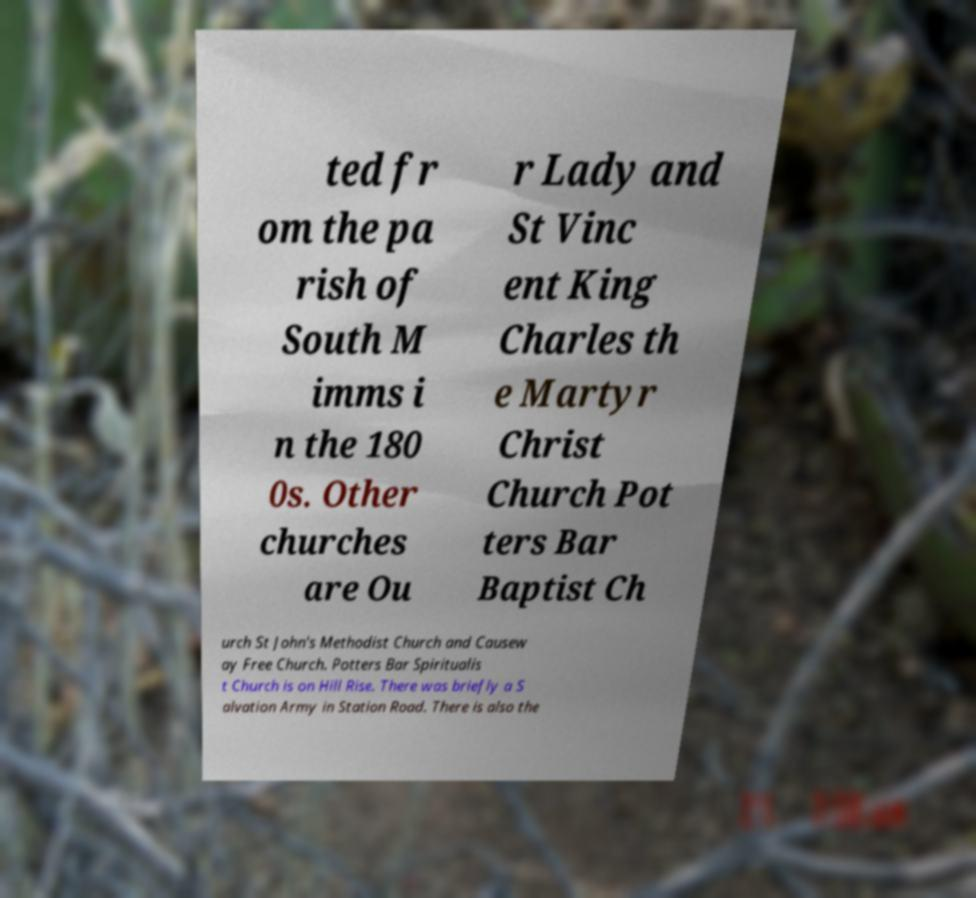I need the written content from this picture converted into text. Can you do that? ted fr om the pa rish of South M imms i n the 180 0s. Other churches are Ou r Lady and St Vinc ent King Charles th e Martyr Christ Church Pot ters Bar Baptist Ch urch St John's Methodist Church and Causew ay Free Church. Potters Bar Spiritualis t Church is on Hill Rise. There was briefly a S alvation Army in Station Road. There is also the 